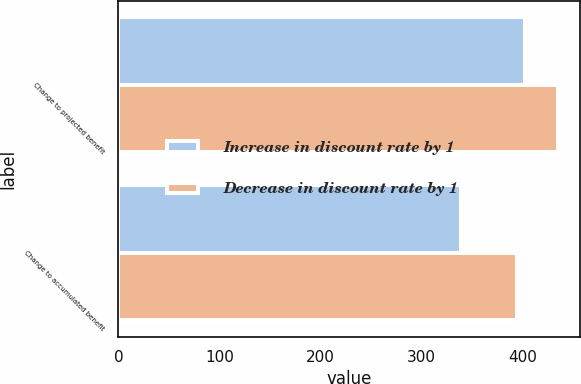Convert chart to OTSL. <chart><loc_0><loc_0><loc_500><loc_500><stacked_bar_chart><ecel><fcel>Change to projected benefit<fcel>Change to accumulated benefit<nl><fcel>Increase in discount rate by 1<fcel>402<fcel>339<nl><fcel>Decrease in discount rate by 1<fcel>435<fcel>394<nl></chart> 